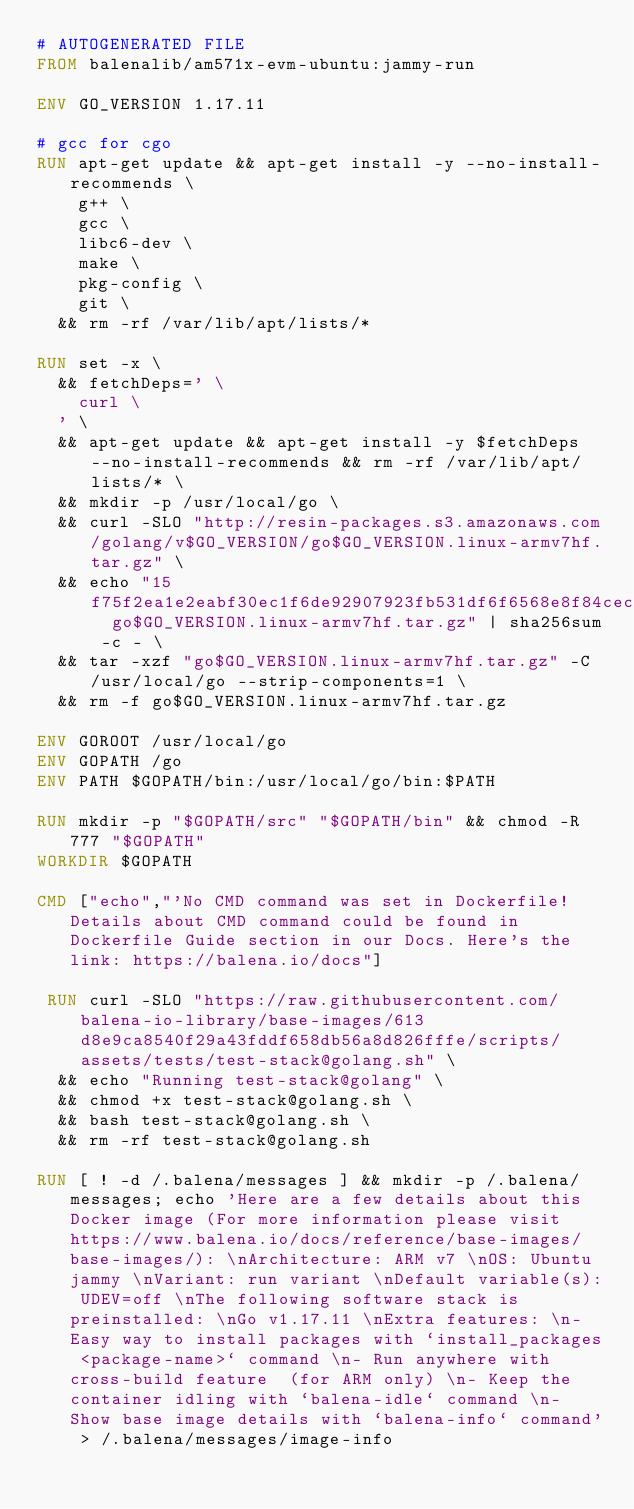Convert code to text. <code><loc_0><loc_0><loc_500><loc_500><_Dockerfile_># AUTOGENERATED FILE
FROM balenalib/am571x-evm-ubuntu:jammy-run

ENV GO_VERSION 1.17.11

# gcc for cgo
RUN apt-get update && apt-get install -y --no-install-recommends \
		g++ \
		gcc \
		libc6-dev \
		make \
		pkg-config \
		git \
	&& rm -rf /var/lib/apt/lists/*

RUN set -x \
	&& fetchDeps=' \
		curl \
	' \
	&& apt-get update && apt-get install -y $fetchDeps --no-install-recommends && rm -rf /var/lib/apt/lists/* \
	&& mkdir -p /usr/local/go \
	&& curl -SLO "http://resin-packages.s3.amazonaws.com/golang/v$GO_VERSION/go$GO_VERSION.linux-armv7hf.tar.gz" \
	&& echo "15f75f2ea1e2eabf30ec1f6de92907923fb531df6f6568e8f84cec5f5f5c9e8d  go$GO_VERSION.linux-armv7hf.tar.gz" | sha256sum -c - \
	&& tar -xzf "go$GO_VERSION.linux-armv7hf.tar.gz" -C /usr/local/go --strip-components=1 \
	&& rm -f go$GO_VERSION.linux-armv7hf.tar.gz

ENV GOROOT /usr/local/go
ENV GOPATH /go
ENV PATH $GOPATH/bin:/usr/local/go/bin:$PATH

RUN mkdir -p "$GOPATH/src" "$GOPATH/bin" && chmod -R 777 "$GOPATH"
WORKDIR $GOPATH

CMD ["echo","'No CMD command was set in Dockerfile! Details about CMD command could be found in Dockerfile Guide section in our Docs. Here's the link: https://balena.io/docs"]

 RUN curl -SLO "https://raw.githubusercontent.com/balena-io-library/base-images/613d8e9ca8540f29a43fddf658db56a8d826fffe/scripts/assets/tests/test-stack@golang.sh" \
  && echo "Running test-stack@golang" \
  && chmod +x test-stack@golang.sh \
  && bash test-stack@golang.sh \
  && rm -rf test-stack@golang.sh 

RUN [ ! -d /.balena/messages ] && mkdir -p /.balena/messages; echo 'Here are a few details about this Docker image (For more information please visit https://www.balena.io/docs/reference/base-images/base-images/): \nArchitecture: ARM v7 \nOS: Ubuntu jammy \nVariant: run variant \nDefault variable(s): UDEV=off \nThe following software stack is preinstalled: \nGo v1.17.11 \nExtra features: \n- Easy way to install packages with `install_packages <package-name>` command \n- Run anywhere with cross-build feature  (for ARM only) \n- Keep the container idling with `balena-idle` command \n- Show base image details with `balena-info` command' > /.balena/messages/image-info</code> 